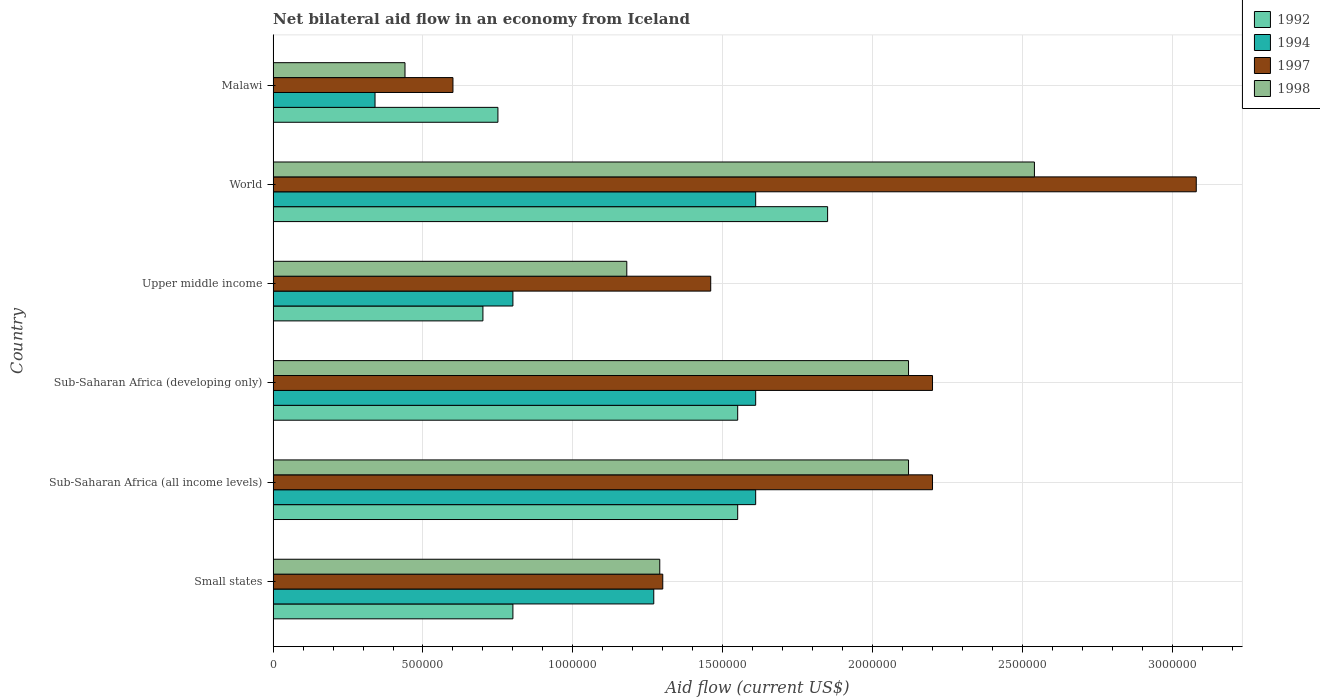How many different coloured bars are there?
Your answer should be very brief. 4. How many groups of bars are there?
Provide a short and direct response. 6. Are the number of bars per tick equal to the number of legend labels?
Ensure brevity in your answer.  Yes. How many bars are there on the 4th tick from the top?
Provide a succinct answer. 4. What is the label of the 3rd group of bars from the top?
Make the answer very short. Upper middle income. What is the net bilateral aid flow in 1998 in Upper middle income?
Offer a terse response. 1.18e+06. Across all countries, what is the maximum net bilateral aid flow in 1997?
Keep it short and to the point. 3.08e+06. In which country was the net bilateral aid flow in 1997 maximum?
Your answer should be compact. World. In which country was the net bilateral aid flow in 1994 minimum?
Offer a very short reply. Malawi. What is the total net bilateral aid flow in 1994 in the graph?
Make the answer very short. 7.24e+06. What is the average net bilateral aid flow in 1992 per country?
Your answer should be very brief. 1.20e+06. What is the difference between the net bilateral aid flow in 1998 and net bilateral aid flow in 1994 in Sub-Saharan Africa (all income levels)?
Ensure brevity in your answer.  5.10e+05. What is the ratio of the net bilateral aid flow in 1997 in Sub-Saharan Africa (developing only) to that in Upper middle income?
Provide a succinct answer. 1.51. What is the difference between the highest and the lowest net bilateral aid flow in 1998?
Ensure brevity in your answer.  2.10e+06. Is the sum of the net bilateral aid flow in 1997 in Sub-Saharan Africa (all income levels) and World greater than the maximum net bilateral aid flow in 1992 across all countries?
Keep it short and to the point. Yes. What does the 4th bar from the top in Small states represents?
Make the answer very short. 1992. Is it the case that in every country, the sum of the net bilateral aid flow in 1998 and net bilateral aid flow in 1997 is greater than the net bilateral aid flow in 1994?
Your answer should be compact. Yes. Are all the bars in the graph horizontal?
Ensure brevity in your answer.  Yes. How are the legend labels stacked?
Provide a short and direct response. Vertical. What is the title of the graph?
Provide a short and direct response. Net bilateral aid flow in an economy from Iceland. Does "1984" appear as one of the legend labels in the graph?
Make the answer very short. No. What is the label or title of the Y-axis?
Offer a very short reply. Country. What is the Aid flow (current US$) in 1992 in Small states?
Offer a very short reply. 8.00e+05. What is the Aid flow (current US$) of 1994 in Small states?
Your answer should be compact. 1.27e+06. What is the Aid flow (current US$) of 1997 in Small states?
Your answer should be compact. 1.30e+06. What is the Aid flow (current US$) in 1998 in Small states?
Give a very brief answer. 1.29e+06. What is the Aid flow (current US$) of 1992 in Sub-Saharan Africa (all income levels)?
Give a very brief answer. 1.55e+06. What is the Aid flow (current US$) of 1994 in Sub-Saharan Africa (all income levels)?
Make the answer very short. 1.61e+06. What is the Aid flow (current US$) in 1997 in Sub-Saharan Africa (all income levels)?
Offer a terse response. 2.20e+06. What is the Aid flow (current US$) of 1998 in Sub-Saharan Africa (all income levels)?
Make the answer very short. 2.12e+06. What is the Aid flow (current US$) in 1992 in Sub-Saharan Africa (developing only)?
Provide a short and direct response. 1.55e+06. What is the Aid flow (current US$) of 1994 in Sub-Saharan Africa (developing only)?
Provide a short and direct response. 1.61e+06. What is the Aid flow (current US$) of 1997 in Sub-Saharan Africa (developing only)?
Provide a short and direct response. 2.20e+06. What is the Aid flow (current US$) in 1998 in Sub-Saharan Africa (developing only)?
Your answer should be very brief. 2.12e+06. What is the Aid flow (current US$) in 1992 in Upper middle income?
Your response must be concise. 7.00e+05. What is the Aid flow (current US$) in 1994 in Upper middle income?
Offer a terse response. 8.00e+05. What is the Aid flow (current US$) of 1997 in Upper middle income?
Give a very brief answer. 1.46e+06. What is the Aid flow (current US$) of 1998 in Upper middle income?
Give a very brief answer. 1.18e+06. What is the Aid flow (current US$) in 1992 in World?
Ensure brevity in your answer.  1.85e+06. What is the Aid flow (current US$) of 1994 in World?
Your response must be concise. 1.61e+06. What is the Aid flow (current US$) in 1997 in World?
Your answer should be compact. 3.08e+06. What is the Aid flow (current US$) of 1998 in World?
Your response must be concise. 2.54e+06. What is the Aid flow (current US$) of 1992 in Malawi?
Give a very brief answer. 7.50e+05. What is the Aid flow (current US$) of 1994 in Malawi?
Ensure brevity in your answer.  3.40e+05. Across all countries, what is the maximum Aid flow (current US$) of 1992?
Your answer should be very brief. 1.85e+06. Across all countries, what is the maximum Aid flow (current US$) in 1994?
Your response must be concise. 1.61e+06. Across all countries, what is the maximum Aid flow (current US$) in 1997?
Offer a very short reply. 3.08e+06. Across all countries, what is the maximum Aid flow (current US$) in 1998?
Your answer should be very brief. 2.54e+06. Across all countries, what is the minimum Aid flow (current US$) of 1992?
Make the answer very short. 7.00e+05. Across all countries, what is the minimum Aid flow (current US$) in 1994?
Offer a very short reply. 3.40e+05. Across all countries, what is the minimum Aid flow (current US$) of 1997?
Provide a short and direct response. 6.00e+05. What is the total Aid flow (current US$) of 1992 in the graph?
Your answer should be compact. 7.20e+06. What is the total Aid flow (current US$) in 1994 in the graph?
Your answer should be very brief. 7.24e+06. What is the total Aid flow (current US$) in 1997 in the graph?
Provide a short and direct response. 1.08e+07. What is the total Aid flow (current US$) in 1998 in the graph?
Provide a short and direct response. 9.69e+06. What is the difference between the Aid flow (current US$) of 1992 in Small states and that in Sub-Saharan Africa (all income levels)?
Make the answer very short. -7.50e+05. What is the difference between the Aid flow (current US$) in 1994 in Small states and that in Sub-Saharan Africa (all income levels)?
Keep it short and to the point. -3.40e+05. What is the difference between the Aid flow (current US$) in 1997 in Small states and that in Sub-Saharan Africa (all income levels)?
Give a very brief answer. -9.00e+05. What is the difference between the Aid flow (current US$) in 1998 in Small states and that in Sub-Saharan Africa (all income levels)?
Keep it short and to the point. -8.30e+05. What is the difference between the Aid flow (current US$) in 1992 in Small states and that in Sub-Saharan Africa (developing only)?
Your response must be concise. -7.50e+05. What is the difference between the Aid flow (current US$) of 1997 in Small states and that in Sub-Saharan Africa (developing only)?
Provide a succinct answer. -9.00e+05. What is the difference between the Aid flow (current US$) in 1998 in Small states and that in Sub-Saharan Africa (developing only)?
Your answer should be very brief. -8.30e+05. What is the difference between the Aid flow (current US$) in 1998 in Small states and that in Upper middle income?
Provide a succinct answer. 1.10e+05. What is the difference between the Aid flow (current US$) of 1992 in Small states and that in World?
Provide a succinct answer. -1.05e+06. What is the difference between the Aid flow (current US$) of 1997 in Small states and that in World?
Make the answer very short. -1.78e+06. What is the difference between the Aid flow (current US$) of 1998 in Small states and that in World?
Your response must be concise. -1.25e+06. What is the difference between the Aid flow (current US$) in 1994 in Small states and that in Malawi?
Your answer should be very brief. 9.30e+05. What is the difference between the Aid flow (current US$) in 1997 in Small states and that in Malawi?
Ensure brevity in your answer.  7.00e+05. What is the difference between the Aid flow (current US$) in 1998 in Small states and that in Malawi?
Provide a short and direct response. 8.50e+05. What is the difference between the Aid flow (current US$) in 1997 in Sub-Saharan Africa (all income levels) and that in Sub-Saharan Africa (developing only)?
Your response must be concise. 0. What is the difference between the Aid flow (current US$) of 1992 in Sub-Saharan Africa (all income levels) and that in Upper middle income?
Provide a short and direct response. 8.50e+05. What is the difference between the Aid flow (current US$) in 1994 in Sub-Saharan Africa (all income levels) and that in Upper middle income?
Your response must be concise. 8.10e+05. What is the difference between the Aid flow (current US$) in 1997 in Sub-Saharan Africa (all income levels) and that in Upper middle income?
Your answer should be very brief. 7.40e+05. What is the difference between the Aid flow (current US$) in 1998 in Sub-Saharan Africa (all income levels) and that in Upper middle income?
Offer a terse response. 9.40e+05. What is the difference between the Aid flow (current US$) in 1994 in Sub-Saharan Africa (all income levels) and that in World?
Ensure brevity in your answer.  0. What is the difference between the Aid flow (current US$) of 1997 in Sub-Saharan Africa (all income levels) and that in World?
Provide a short and direct response. -8.80e+05. What is the difference between the Aid flow (current US$) of 1998 in Sub-Saharan Africa (all income levels) and that in World?
Ensure brevity in your answer.  -4.20e+05. What is the difference between the Aid flow (current US$) in 1994 in Sub-Saharan Africa (all income levels) and that in Malawi?
Offer a very short reply. 1.27e+06. What is the difference between the Aid flow (current US$) in 1997 in Sub-Saharan Africa (all income levels) and that in Malawi?
Offer a terse response. 1.60e+06. What is the difference between the Aid flow (current US$) in 1998 in Sub-Saharan Africa (all income levels) and that in Malawi?
Offer a very short reply. 1.68e+06. What is the difference between the Aid flow (current US$) in 1992 in Sub-Saharan Africa (developing only) and that in Upper middle income?
Offer a very short reply. 8.50e+05. What is the difference between the Aid flow (current US$) of 1994 in Sub-Saharan Africa (developing only) and that in Upper middle income?
Your answer should be very brief. 8.10e+05. What is the difference between the Aid flow (current US$) of 1997 in Sub-Saharan Africa (developing only) and that in Upper middle income?
Provide a succinct answer. 7.40e+05. What is the difference between the Aid flow (current US$) in 1998 in Sub-Saharan Africa (developing only) and that in Upper middle income?
Offer a very short reply. 9.40e+05. What is the difference between the Aid flow (current US$) in 1992 in Sub-Saharan Africa (developing only) and that in World?
Provide a short and direct response. -3.00e+05. What is the difference between the Aid flow (current US$) in 1997 in Sub-Saharan Africa (developing only) and that in World?
Offer a very short reply. -8.80e+05. What is the difference between the Aid flow (current US$) of 1998 in Sub-Saharan Africa (developing only) and that in World?
Your answer should be very brief. -4.20e+05. What is the difference between the Aid flow (current US$) in 1992 in Sub-Saharan Africa (developing only) and that in Malawi?
Your response must be concise. 8.00e+05. What is the difference between the Aid flow (current US$) in 1994 in Sub-Saharan Africa (developing only) and that in Malawi?
Offer a very short reply. 1.27e+06. What is the difference between the Aid flow (current US$) of 1997 in Sub-Saharan Africa (developing only) and that in Malawi?
Your answer should be compact. 1.60e+06. What is the difference between the Aid flow (current US$) in 1998 in Sub-Saharan Africa (developing only) and that in Malawi?
Your response must be concise. 1.68e+06. What is the difference between the Aid flow (current US$) of 1992 in Upper middle income and that in World?
Ensure brevity in your answer.  -1.15e+06. What is the difference between the Aid flow (current US$) of 1994 in Upper middle income and that in World?
Give a very brief answer. -8.10e+05. What is the difference between the Aid flow (current US$) in 1997 in Upper middle income and that in World?
Ensure brevity in your answer.  -1.62e+06. What is the difference between the Aid flow (current US$) of 1998 in Upper middle income and that in World?
Give a very brief answer. -1.36e+06. What is the difference between the Aid flow (current US$) of 1992 in Upper middle income and that in Malawi?
Give a very brief answer. -5.00e+04. What is the difference between the Aid flow (current US$) of 1997 in Upper middle income and that in Malawi?
Offer a very short reply. 8.60e+05. What is the difference between the Aid flow (current US$) in 1998 in Upper middle income and that in Malawi?
Give a very brief answer. 7.40e+05. What is the difference between the Aid flow (current US$) of 1992 in World and that in Malawi?
Your answer should be very brief. 1.10e+06. What is the difference between the Aid flow (current US$) of 1994 in World and that in Malawi?
Your answer should be compact. 1.27e+06. What is the difference between the Aid flow (current US$) in 1997 in World and that in Malawi?
Make the answer very short. 2.48e+06. What is the difference between the Aid flow (current US$) of 1998 in World and that in Malawi?
Your answer should be compact. 2.10e+06. What is the difference between the Aid flow (current US$) of 1992 in Small states and the Aid flow (current US$) of 1994 in Sub-Saharan Africa (all income levels)?
Your response must be concise. -8.10e+05. What is the difference between the Aid flow (current US$) of 1992 in Small states and the Aid flow (current US$) of 1997 in Sub-Saharan Africa (all income levels)?
Provide a short and direct response. -1.40e+06. What is the difference between the Aid flow (current US$) of 1992 in Small states and the Aid flow (current US$) of 1998 in Sub-Saharan Africa (all income levels)?
Your answer should be very brief. -1.32e+06. What is the difference between the Aid flow (current US$) of 1994 in Small states and the Aid flow (current US$) of 1997 in Sub-Saharan Africa (all income levels)?
Your response must be concise. -9.30e+05. What is the difference between the Aid flow (current US$) of 1994 in Small states and the Aid flow (current US$) of 1998 in Sub-Saharan Africa (all income levels)?
Offer a terse response. -8.50e+05. What is the difference between the Aid flow (current US$) in 1997 in Small states and the Aid flow (current US$) in 1998 in Sub-Saharan Africa (all income levels)?
Your answer should be compact. -8.20e+05. What is the difference between the Aid flow (current US$) in 1992 in Small states and the Aid flow (current US$) in 1994 in Sub-Saharan Africa (developing only)?
Ensure brevity in your answer.  -8.10e+05. What is the difference between the Aid flow (current US$) in 1992 in Small states and the Aid flow (current US$) in 1997 in Sub-Saharan Africa (developing only)?
Your answer should be compact. -1.40e+06. What is the difference between the Aid flow (current US$) of 1992 in Small states and the Aid flow (current US$) of 1998 in Sub-Saharan Africa (developing only)?
Your response must be concise. -1.32e+06. What is the difference between the Aid flow (current US$) in 1994 in Small states and the Aid flow (current US$) in 1997 in Sub-Saharan Africa (developing only)?
Offer a terse response. -9.30e+05. What is the difference between the Aid flow (current US$) of 1994 in Small states and the Aid flow (current US$) of 1998 in Sub-Saharan Africa (developing only)?
Offer a very short reply. -8.50e+05. What is the difference between the Aid flow (current US$) of 1997 in Small states and the Aid flow (current US$) of 1998 in Sub-Saharan Africa (developing only)?
Make the answer very short. -8.20e+05. What is the difference between the Aid flow (current US$) in 1992 in Small states and the Aid flow (current US$) in 1997 in Upper middle income?
Offer a terse response. -6.60e+05. What is the difference between the Aid flow (current US$) of 1992 in Small states and the Aid flow (current US$) of 1998 in Upper middle income?
Your answer should be very brief. -3.80e+05. What is the difference between the Aid flow (current US$) of 1994 in Small states and the Aid flow (current US$) of 1998 in Upper middle income?
Make the answer very short. 9.00e+04. What is the difference between the Aid flow (current US$) of 1997 in Small states and the Aid flow (current US$) of 1998 in Upper middle income?
Keep it short and to the point. 1.20e+05. What is the difference between the Aid flow (current US$) in 1992 in Small states and the Aid flow (current US$) in 1994 in World?
Your response must be concise. -8.10e+05. What is the difference between the Aid flow (current US$) in 1992 in Small states and the Aid flow (current US$) in 1997 in World?
Ensure brevity in your answer.  -2.28e+06. What is the difference between the Aid flow (current US$) in 1992 in Small states and the Aid flow (current US$) in 1998 in World?
Provide a short and direct response. -1.74e+06. What is the difference between the Aid flow (current US$) in 1994 in Small states and the Aid flow (current US$) in 1997 in World?
Ensure brevity in your answer.  -1.81e+06. What is the difference between the Aid flow (current US$) of 1994 in Small states and the Aid flow (current US$) of 1998 in World?
Ensure brevity in your answer.  -1.27e+06. What is the difference between the Aid flow (current US$) of 1997 in Small states and the Aid flow (current US$) of 1998 in World?
Offer a terse response. -1.24e+06. What is the difference between the Aid flow (current US$) of 1992 in Small states and the Aid flow (current US$) of 1998 in Malawi?
Give a very brief answer. 3.60e+05. What is the difference between the Aid flow (current US$) in 1994 in Small states and the Aid flow (current US$) in 1997 in Malawi?
Offer a terse response. 6.70e+05. What is the difference between the Aid flow (current US$) of 1994 in Small states and the Aid flow (current US$) of 1998 in Malawi?
Your answer should be very brief. 8.30e+05. What is the difference between the Aid flow (current US$) in 1997 in Small states and the Aid flow (current US$) in 1998 in Malawi?
Offer a terse response. 8.60e+05. What is the difference between the Aid flow (current US$) in 1992 in Sub-Saharan Africa (all income levels) and the Aid flow (current US$) in 1994 in Sub-Saharan Africa (developing only)?
Keep it short and to the point. -6.00e+04. What is the difference between the Aid flow (current US$) of 1992 in Sub-Saharan Africa (all income levels) and the Aid flow (current US$) of 1997 in Sub-Saharan Africa (developing only)?
Ensure brevity in your answer.  -6.50e+05. What is the difference between the Aid flow (current US$) in 1992 in Sub-Saharan Africa (all income levels) and the Aid flow (current US$) in 1998 in Sub-Saharan Africa (developing only)?
Your answer should be very brief. -5.70e+05. What is the difference between the Aid flow (current US$) of 1994 in Sub-Saharan Africa (all income levels) and the Aid flow (current US$) of 1997 in Sub-Saharan Africa (developing only)?
Give a very brief answer. -5.90e+05. What is the difference between the Aid flow (current US$) of 1994 in Sub-Saharan Africa (all income levels) and the Aid flow (current US$) of 1998 in Sub-Saharan Africa (developing only)?
Make the answer very short. -5.10e+05. What is the difference between the Aid flow (current US$) of 1997 in Sub-Saharan Africa (all income levels) and the Aid flow (current US$) of 1998 in Sub-Saharan Africa (developing only)?
Make the answer very short. 8.00e+04. What is the difference between the Aid flow (current US$) of 1992 in Sub-Saharan Africa (all income levels) and the Aid flow (current US$) of 1994 in Upper middle income?
Your response must be concise. 7.50e+05. What is the difference between the Aid flow (current US$) of 1992 in Sub-Saharan Africa (all income levels) and the Aid flow (current US$) of 1997 in Upper middle income?
Your response must be concise. 9.00e+04. What is the difference between the Aid flow (current US$) in 1994 in Sub-Saharan Africa (all income levels) and the Aid flow (current US$) in 1998 in Upper middle income?
Offer a terse response. 4.30e+05. What is the difference between the Aid flow (current US$) in 1997 in Sub-Saharan Africa (all income levels) and the Aid flow (current US$) in 1998 in Upper middle income?
Provide a succinct answer. 1.02e+06. What is the difference between the Aid flow (current US$) of 1992 in Sub-Saharan Africa (all income levels) and the Aid flow (current US$) of 1997 in World?
Make the answer very short. -1.53e+06. What is the difference between the Aid flow (current US$) in 1992 in Sub-Saharan Africa (all income levels) and the Aid flow (current US$) in 1998 in World?
Your response must be concise. -9.90e+05. What is the difference between the Aid flow (current US$) in 1994 in Sub-Saharan Africa (all income levels) and the Aid flow (current US$) in 1997 in World?
Your answer should be very brief. -1.47e+06. What is the difference between the Aid flow (current US$) in 1994 in Sub-Saharan Africa (all income levels) and the Aid flow (current US$) in 1998 in World?
Keep it short and to the point. -9.30e+05. What is the difference between the Aid flow (current US$) of 1997 in Sub-Saharan Africa (all income levels) and the Aid flow (current US$) of 1998 in World?
Your response must be concise. -3.40e+05. What is the difference between the Aid flow (current US$) in 1992 in Sub-Saharan Africa (all income levels) and the Aid flow (current US$) in 1994 in Malawi?
Provide a succinct answer. 1.21e+06. What is the difference between the Aid flow (current US$) in 1992 in Sub-Saharan Africa (all income levels) and the Aid flow (current US$) in 1997 in Malawi?
Ensure brevity in your answer.  9.50e+05. What is the difference between the Aid flow (current US$) of 1992 in Sub-Saharan Africa (all income levels) and the Aid flow (current US$) of 1998 in Malawi?
Offer a terse response. 1.11e+06. What is the difference between the Aid flow (current US$) in 1994 in Sub-Saharan Africa (all income levels) and the Aid flow (current US$) in 1997 in Malawi?
Provide a succinct answer. 1.01e+06. What is the difference between the Aid flow (current US$) of 1994 in Sub-Saharan Africa (all income levels) and the Aid flow (current US$) of 1998 in Malawi?
Your response must be concise. 1.17e+06. What is the difference between the Aid flow (current US$) of 1997 in Sub-Saharan Africa (all income levels) and the Aid flow (current US$) of 1998 in Malawi?
Make the answer very short. 1.76e+06. What is the difference between the Aid flow (current US$) of 1992 in Sub-Saharan Africa (developing only) and the Aid flow (current US$) of 1994 in Upper middle income?
Give a very brief answer. 7.50e+05. What is the difference between the Aid flow (current US$) of 1992 in Sub-Saharan Africa (developing only) and the Aid flow (current US$) of 1997 in Upper middle income?
Your answer should be compact. 9.00e+04. What is the difference between the Aid flow (current US$) in 1997 in Sub-Saharan Africa (developing only) and the Aid flow (current US$) in 1998 in Upper middle income?
Your answer should be very brief. 1.02e+06. What is the difference between the Aid flow (current US$) in 1992 in Sub-Saharan Africa (developing only) and the Aid flow (current US$) in 1994 in World?
Make the answer very short. -6.00e+04. What is the difference between the Aid flow (current US$) in 1992 in Sub-Saharan Africa (developing only) and the Aid flow (current US$) in 1997 in World?
Your answer should be very brief. -1.53e+06. What is the difference between the Aid flow (current US$) of 1992 in Sub-Saharan Africa (developing only) and the Aid flow (current US$) of 1998 in World?
Your answer should be very brief. -9.90e+05. What is the difference between the Aid flow (current US$) of 1994 in Sub-Saharan Africa (developing only) and the Aid flow (current US$) of 1997 in World?
Your answer should be very brief. -1.47e+06. What is the difference between the Aid flow (current US$) in 1994 in Sub-Saharan Africa (developing only) and the Aid flow (current US$) in 1998 in World?
Offer a terse response. -9.30e+05. What is the difference between the Aid flow (current US$) in 1997 in Sub-Saharan Africa (developing only) and the Aid flow (current US$) in 1998 in World?
Keep it short and to the point. -3.40e+05. What is the difference between the Aid flow (current US$) of 1992 in Sub-Saharan Africa (developing only) and the Aid flow (current US$) of 1994 in Malawi?
Provide a succinct answer. 1.21e+06. What is the difference between the Aid flow (current US$) of 1992 in Sub-Saharan Africa (developing only) and the Aid flow (current US$) of 1997 in Malawi?
Your answer should be compact. 9.50e+05. What is the difference between the Aid flow (current US$) in 1992 in Sub-Saharan Africa (developing only) and the Aid flow (current US$) in 1998 in Malawi?
Ensure brevity in your answer.  1.11e+06. What is the difference between the Aid flow (current US$) of 1994 in Sub-Saharan Africa (developing only) and the Aid flow (current US$) of 1997 in Malawi?
Your response must be concise. 1.01e+06. What is the difference between the Aid flow (current US$) of 1994 in Sub-Saharan Africa (developing only) and the Aid flow (current US$) of 1998 in Malawi?
Provide a short and direct response. 1.17e+06. What is the difference between the Aid flow (current US$) in 1997 in Sub-Saharan Africa (developing only) and the Aid flow (current US$) in 1998 in Malawi?
Make the answer very short. 1.76e+06. What is the difference between the Aid flow (current US$) of 1992 in Upper middle income and the Aid flow (current US$) of 1994 in World?
Your answer should be compact. -9.10e+05. What is the difference between the Aid flow (current US$) in 1992 in Upper middle income and the Aid flow (current US$) in 1997 in World?
Your answer should be compact. -2.38e+06. What is the difference between the Aid flow (current US$) in 1992 in Upper middle income and the Aid flow (current US$) in 1998 in World?
Ensure brevity in your answer.  -1.84e+06. What is the difference between the Aid flow (current US$) in 1994 in Upper middle income and the Aid flow (current US$) in 1997 in World?
Offer a very short reply. -2.28e+06. What is the difference between the Aid flow (current US$) of 1994 in Upper middle income and the Aid flow (current US$) of 1998 in World?
Provide a short and direct response. -1.74e+06. What is the difference between the Aid flow (current US$) of 1997 in Upper middle income and the Aid flow (current US$) of 1998 in World?
Provide a short and direct response. -1.08e+06. What is the difference between the Aid flow (current US$) of 1992 in Upper middle income and the Aid flow (current US$) of 1998 in Malawi?
Offer a very short reply. 2.60e+05. What is the difference between the Aid flow (current US$) of 1994 in Upper middle income and the Aid flow (current US$) of 1997 in Malawi?
Offer a terse response. 2.00e+05. What is the difference between the Aid flow (current US$) of 1994 in Upper middle income and the Aid flow (current US$) of 1998 in Malawi?
Keep it short and to the point. 3.60e+05. What is the difference between the Aid flow (current US$) in 1997 in Upper middle income and the Aid flow (current US$) in 1998 in Malawi?
Your answer should be very brief. 1.02e+06. What is the difference between the Aid flow (current US$) of 1992 in World and the Aid flow (current US$) of 1994 in Malawi?
Make the answer very short. 1.51e+06. What is the difference between the Aid flow (current US$) in 1992 in World and the Aid flow (current US$) in 1997 in Malawi?
Give a very brief answer. 1.25e+06. What is the difference between the Aid flow (current US$) in 1992 in World and the Aid flow (current US$) in 1998 in Malawi?
Offer a very short reply. 1.41e+06. What is the difference between the Aid flow (current US$) in 1994 in World and the Aid flow (current US$) in 1997 in Malawi?
Offer a terse response. 1.01e+06. What is the difference between the Aid flow (current US$) of 1994 in World and the Aid flow (current US$) of 1998 in Malawi?
Keep it short and to the point. 1.17e+06. What is the difference between the Aid flow (current US$) of 1997 in World and the Aid flow (current US$) of 1998 in Malawi?
Your response must be concise. 2.64e+06. What is the average Aid flow (current US$) of 1992 per country?
Provide a short and direct response. 1.20e+06. What is the average Aid flow (current US$) in 1994 per country?
Your response must be concise. 1.21e+06. What is the average Aid flow (current US$) of 1997 per country?
Make the answer very short. 1.81e+06. What is the average Aid flow (current US$) of 1998 per country?
Provide a succinct answer. 1.62e+06. What is the difference between the Aid flow (current US$) of 1992 and Aid flow (current US$) of 1994 in Small states?
Ensure brevity in your answer.  -4.70e+05. What is the difference between the Aid flow (current US$) in 1992 and Aid flow (current US$) in 1997 in Small states?
Offer a very short reply. -5.00e+05. What is the difference between the Aid flow (current US$) of 1992 and Aid flow (current US$) of 1998 in Small states?
Give a very brief answer. -4.90e+05. What is the difference between the Aid flow (current US$) in 1992 and Aid flow (current US$) in 1997 in Sub-Saharan Africa (all income levels)?
Your response must be concise. -6.50e+05. What is the difference between the Aid flow (current US$) of 1992 and Aid flow (current US$) of 1998 in Sub-Saharan Africa (all income levels)?
Offer a terse response. -5.70e+05. What is the difference between the Aid flow (current US$) in 1994 and Aid flow (current US$) in 1997 in Sub-Saharan Africa (all income levels)?
Provide a succinct answer. -5.90e+05. What is the difference between the Aid flow (current US$) of 1994 and Aid flow (current US$) of 1998 in Sub-Saharan Africa (all income levels)?
Your answer should be very brief. -5.10e+05. What is the difference between the Aid flow (current US$) in 1997 and Aid flow (current US$) in 1998 in Sub-Saharan Africa (all income levels)?
Offer a very short reply. 8.00e+04. What is the difference between the Aid flow (current US$) in 1992 and Aid flow (current US$) in 1997 in Sub-Saharan Africa (developing only)?
Ensure brevity in your answer.  -6.50e+05. What is the difference between the Aid flow (current US$) in 1992 and Aid flow (current US$) in 1998 in Sub-Saharan Africa (developing only)?
Give a very brief answer. -5.70e+05. What is the difference between the Aid flow (current US$) in 1994 and Aid flow (current US$) in 1997 in Sub-Saharan Africa (developing only)?
Your answer should be compact. -5.90e+05. What is the difference between the Aid flow (current US$) in 1994 and Aid flow (current US$) in 1998 in Sub-Saharan Africa (developing only)?
Offer a very short reply. -5.10e+05. What is the difference between the Aid flow (current US$) of 1992 and Aid flow (current US$) of 1997 in Upper middle income?
Ensure brevity in your answer.  -7.60e+05. What is the difference between the Aid flow (current US$) in 1992 and Aid flow (current US$) in 1998 in Upper middle income?
Provide a succinct answer. -4.80e+05. What is the difference between the Aid flow (current US$) in 1994 and Aid flow (current US$) in 1997 in Upper middle income?
Keep it short and to the point. -6.60e+05. What is the difference between the Aid flow (current US$) in 1994 and Aid flow (current US$) in 1998 in Upper middle income?
Keep it short and to the point. -3.80e+05. What is the difference between the Aid flow (current US$) of 1997 and Aid flow (current US$) of 1998 in Upper middle income?
Your answer should be compact. 2.80e+05. What is the difference between the Aid flow (current US$) of 1992 and Aid flow (current US$) of 1997 in World?
Ensure brevity in your answer.  -1.23e+06. What is the difference between the Aid flow (current US$) in 1992 and Aid flow (current US$) in 1998 in World?
Provide a short and direct response. -6.90e+05. What is the difference between the Aid flow (current US$) in 1994 and Aid flow (current US$) in 1997 in World?
Your answer should be compact. -1.47e+06. What is the difference between the Aid flow (current US$) of 1994 and Aid flow (current US$) of 1998 in World?
Keep it short and to the point. -9.30e+05. What is the difference between the Aid flow (current US$) in 1997 and Aid flow (current US$) in 1998 in World?
Offer a terse response. 5.40e+05. What is the difference between the Aid flow (current US$) of 1994 and Aid flow (current US$) of 1997 in Malawi?
Your response must be concise. -2.60e+05. What is the difference between the Aid flow (current US$) of 1994 and Aid flow (current US$) of 1998 in Malawi?
Give a very brief answer. -1.00e+05. What is the ratio of the Aid flow (current US$) in 1992 in Small states to that in Sub-Saharan Africa (all income levels)?
Offer a terse response. 0.52. What is the ratio of the Aid flow (current US$) in 1994 in Small states to that in Sub-Saharan Africa (all income levels)?
Your answer should be very brief. 0.79. What is the ratio of the Aid flow (current US$) in 1997 in Small states to that in Sub-Saharan Africa (all income levels)?
Offer a very short reply. 0.59. What is the ratio of the Aid flow (current US$) of 1998 in Small states to that in Sub-Saharan Africa (all income levels)?
Give a very brief answer. 0.61. What is the ratio of the Aid flow (current US$) in 1992 in Small states to that in Sub-Saharan Africa (developing only)?
Keep it short and to the point. 0.52. What is the ratio of the Aid flow (current US$) of 1994 in Small states to that in Sub-Saharan Africa (developing only)?
Ensure brevity in your answer.  0.79. What is the ratio of the Aid flow (current US$) in 1997 in Small states to that in Sub-Saharan Africa (developing only)?
Make the answer very short. 0.59. What is the ratio of the Aid flow (current US$) of 1998 in Small states to that in Sub-Saharan Africa (developing only)?
Keep it short and to the point. 0.61. What is the ratio of the Aid flow (current US$) in 1994 in Small states to that in Upper middle income?
Ensure brevity in your answer.  1.59. What is the ratio of the Aid flow (current US$) in 1997 in Small states to that in Upper middle income?
Give a very brief answer. 0.89. What is the ratio of the Aid flow (current US$) in 1998 in Small states to that in Upper middle income?
Your answer should be compact. 1.09. What is the ratio of the Aid flow (current US$) of 1992 in Small states to that in World?
Provide a short and direct response. 0.43. What is the ratio of the Aid flow (current US$) in 1994 in Small states to that in World?
Your response must be concise. 0.79. What is the ratio of the Aid flow (current US$) of 1997 in Small states to that in World?
Ensure brevity in your answer.  0.42. What is the ratio of the Aid flow (current US$) in 1998 in Small states to that in World?
Offer a very short reply. 0.51. What is the ratio of the Aid flow (current US$) of 1992 in Small states to that in Malawi?
Offer a very short reply. 1.07. What is the ratio of the Aid flow (current US$) in 1994 in Small states to that in Malawi?
Provide a short and direct response. 3.74. What is the ratio of the Aid flow (current US$) of 1997 in Small states to that in Malawi?
Your response must be concise. 2.17. What is the ratio of the Aid flow (current US$) in 1998 in Small states to that in Malawi?
Make the answer very short. 2.93. What is the ratio of the Aid flow (current US$) in 1992 in Sub-Saharan Africa (all income levels) to that in Sub-Saharan Africa (developing only)?
Offer a very short reply. 1. What is the ratio of the Aid flow (current US$) in 1992 in Sub-Saharan Africa (all income levels) to that in Upper middle income?
Your answer should be compact. 2.21. What is the ratio of the Aid flow (current US$) in 1994 in Sub-Saharan Africa (all income levels) to that in Upper middle income?
Your answer should be very brief. 2.01. What is the ratio of the Aid flow (current US$) of 1997 in Sub-Saharan Africa (all income levels) to that in Upper middle income?
Your answer should be very brief. 1.51. What is the ratio of the Aid flow (current US$) of 1998 in Sub-Saharan Africa (all income levels) to that in Upper middle income?
Make the answer very short. 1.8. What is the ratio of the Aid flow (current US$) in 1992 in Sub-Saharan Africa (all income levels) to that in World?
Your response must be concise. 0.84. What is the ratio of the Aid flow (current US$) of 1994 in Sub-Saharan Africa (all income levels) to that in World?
Your response must be concise. 1. What is the ratio of the Aid flow (current US$) in 1998 in Sub-Saharan Africa (all income levels) to that in World?
Your answer should be compact. 0.83. What is the ratio of the Aid flow (current US$) in 1992 in Sub-Saharan Africa (all income levels) to that in Malawi?
Ensure brevity in your answer.  2.07. What is the ratio of the Aid flow (current US$) of 1994 in Sub-Saharan Africa (all income levels) to that in Malawi?
Ensure brevity in your answer.  4.74. What is the ratio of the Aid flow (current US$) of 1997 in Sub-Saharan Africa (all income levels) to that in Malawi?
Provide a short and direct response. 3.67. What is the ratio of the Aid flow (current US$) in 1998 in Sub-Saharan Africa (all income levels) to that in Malawi?
Offer a terse response. 4.82. What is the ratio of the Aid flow (current US$) of 1992 in Sub-Saharan Africa (developing only) to that in Upper middle income?
Your response must be concise. 2.21. What is the ratio of the Aid flow (current US$) of 1994 in Sub-Saharan Africa (developing only) to that in Upper middle income?
Give a very brief answer. 2.01. What is the ratio of the Aid flow (current US$) of 1997 in Sub-Saharan Africa (developing only) to that in Upper middle income?
Provide a succinct answer. 1.51. What is the ratio of the Aid flow (current US$) of 1998 in Sub-Saharan Africa (developing only) to that in Upper middle income?
Offer a terse response. 1.8. What is the ratio of the Aid flow (current US$) of 1992 in Sub-Saharan Africa (developing only) to that in World?
Give a very brief answer. 0.84. What is the ratio of the Aid flow (current US$) of 1997 in Sub-Saharan Africa (developing only) to that in World?
Give a very brief answer. 0.71. What is the ratio of the Aid flow (current US$) of 1998 in Sub-Saharan Africa (developing only) to that in World?
Your answer should be compact. 0.83. What is the ratio of the Aid flow (current US$) of 1992 in Sub-Saharan Africa (developing only) to that in Malawi?
Your response must be concise. 2.07. What is the ratio of the Aid flow (current US$) in 1994 in Sub-Saharan Africa (developing only) to that in Malawi?
Your answer should be very brief. 4.74. What is the ratio of the Aid flow (current US$) in 1997 in Sub-Saharan Africa (developing only) to that in Malawi?
Your answer should be very brief. 3.67. What is the ratio of the Aid flow (current US$) of 1998 in Sub-Saharan Africa (developing only) to that in Malawi?
Offer a terse response. 4.82. What is the ratio of the Aid flow (current US$) in 1992 in Upper middle income to that in World?
Keep it short and to the point. 0.38. What is the ratio of the Aid flow (current US$) in 1994 in Upper middle income to that in World?
Offer a very short reply. 0.5. What is the ratio of the Aid flow (current US$) of 1997 in Upper middle income to that in World?
Give a very brief answer. 0.47. What is the ratio of the Aid flow (current US$) of 1998 in Upper middle income to that in World?
Ensure brevity in your answer.  0.46. What is the ratio of the Aid flow (current US$) of 1992 in Upper middle income to that in Malawi?
Provide a succinct answer. 0.93. What is the ratio of the Aid flow (current US$) of 1994 in Upper middle income to that in Malawi?
Offer a very short reply. 2.35. What is the ratio of the Aid flow (current US$) in 1997 in Upper middle income to that in Malawi?
Keep it short and to the point. 2.43. What is the ratio of the Aid flow (current US$) in 1998 in Upper middle income to that in Malawi?
Give a very brief answer. 2.68. What is the ratio of the Aid flow (current US$) of 1992 in World to that in Malawi?
Your answer should be very brief. 2.47. What is the ratio of the Aid flow (current US$) in 1994 in World to that in Malawi?
Provide a short and direct response. 4.74. What is the ratio of the Aid flow (current US$) of 1997 in World to that in Malawi?
Offer a terse response. 5.13. What is the ratio of the Aid flow (current US$) of 1998 in World to that in Malawi?
Your response must be concise. 5.77. What is the difference between the highest and the second highest Aid flow (current US$) in 1994?
Provide a succinct answer. 0. What is the difference between the highest and the second highest Aid flow (current US$) in 1997?
Your response must be concise. 8.80e+05. What is the difference between the highest and the second highest Aid flow (current US$) of 1998?
Your answer should be very brief. 4.20e+05. What is the difference between the highest and the lowest Aid flow (current US$) of 1992?
Your answer should be compact. 1.15e+06. What is the difference between the highest and the lowest Aid flow (current US$) of 1994?
Keep it short and to the point. 1.27e+06. What is the difference between the highest and the lowest Aid flow (current US$) in 1997?
Ensure brevity in your answer.  2.48e+06. What is the difference between the highest and the lowest Aid flow (current US$) in 1998?
Your answer should be compact. 2.10e+06. 